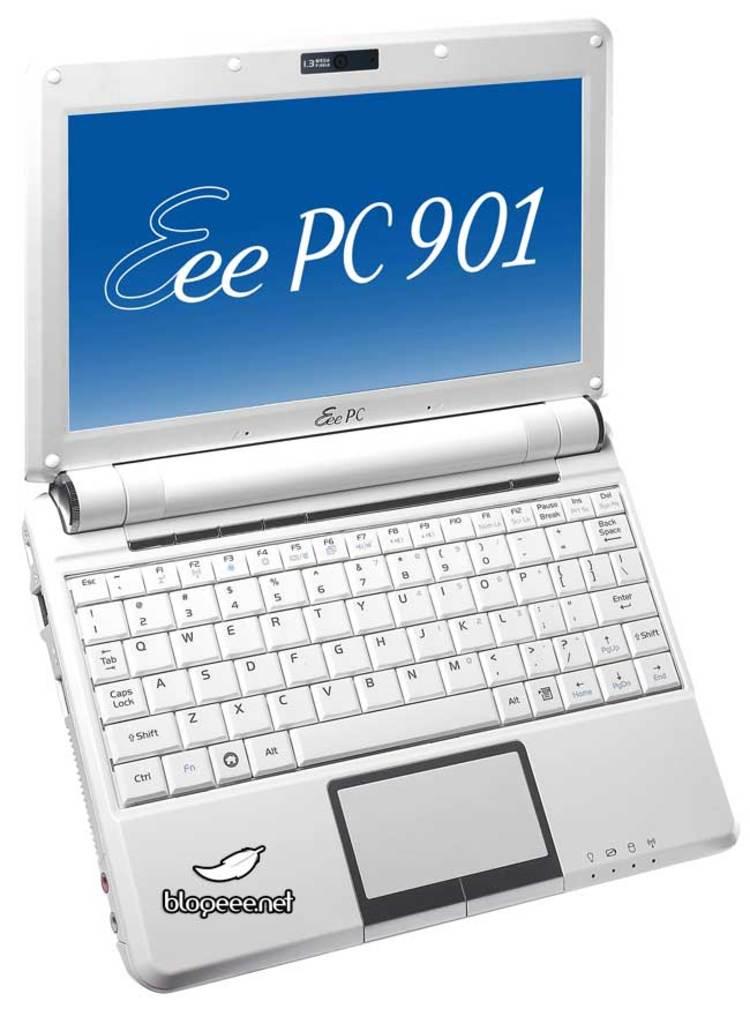What does the screen say?
Offer a very short reply. Eee pc 901. What website is shown?
Offer a very short reply. Eee pc 901. 